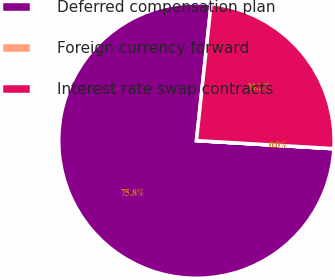Convert chart. <chart><loc_0><loc_0><loc_500><loc_500><pie_chart><fcel>Deferred compensation plan<fcel>Foreign currency forward<fcel>Interest rate swap contracts<nl><fcel>75.76%<fcel>0.01%<fcel>24.23%<nl></chart> 